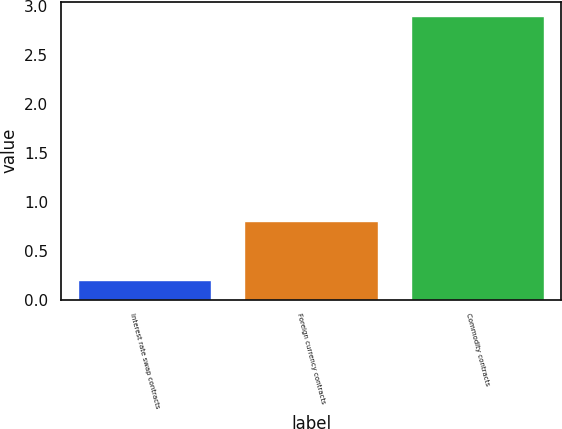Convert chart to OTSL. <chart><loc_0><loc_0><loc_500><loc_500><bar_chart><fcel>Interest rate swap contracts<fcel>Foreign currency contracts<fcel>Commodity contracts<nl><fcel>0.2<fcel>0.8<fcel>2.9<nl></chart> 